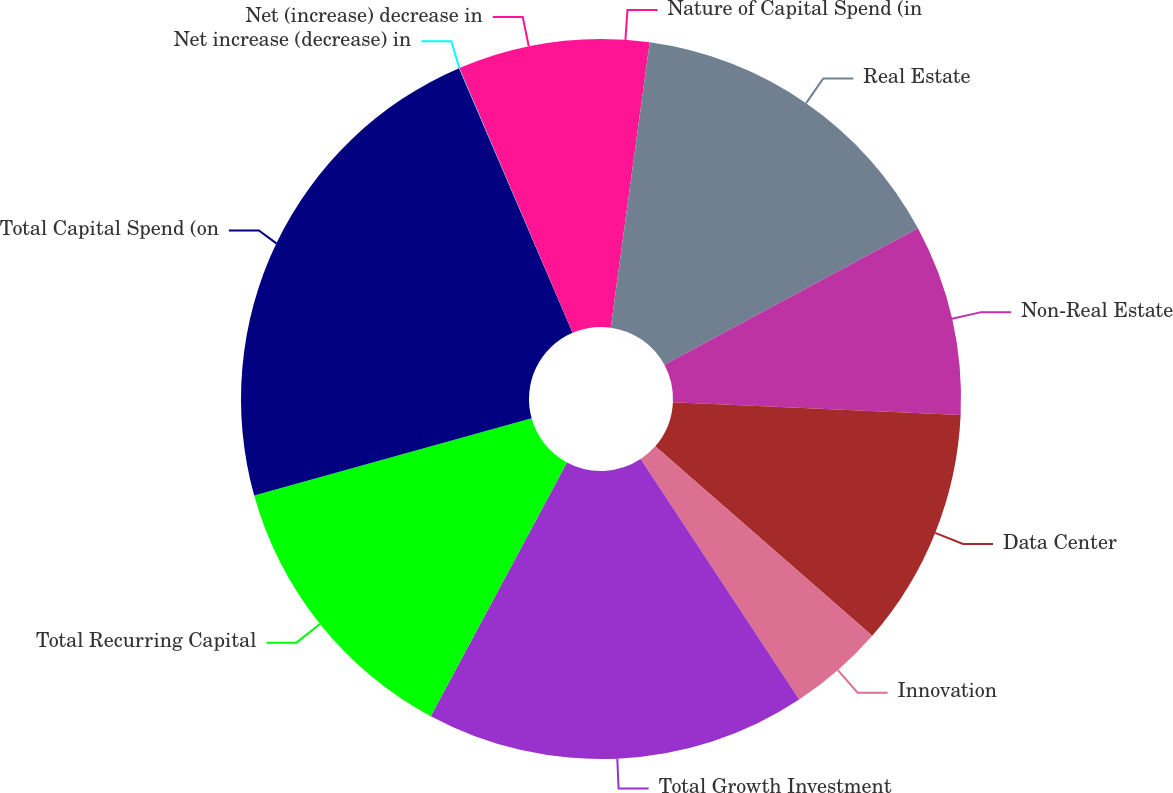<chart> <loc_0><loc_0><loc_500><loc_500><pie_chart><fcel>Nature of Capital Spend (in<fcel>Real Estate<fcel>Non-Real Estate<fcel>Data Center<fcel>Innovation<fcel>Total Growth Investment<fcel>Total Recurring Capital<fcel>Total Capital Spend (on<fcel>Net increase (decrease) in<fcel>Net (increase) decrease in<nl><fcel>2.16%<fcel>14.98%<fcel>8.57%<fcel>10.71%<fcel>4.3%<fcel>17.12%<fcel>12.84%<fcel>22.87%<fcel>0.02%<fcel>6.43%<nl></chart> 